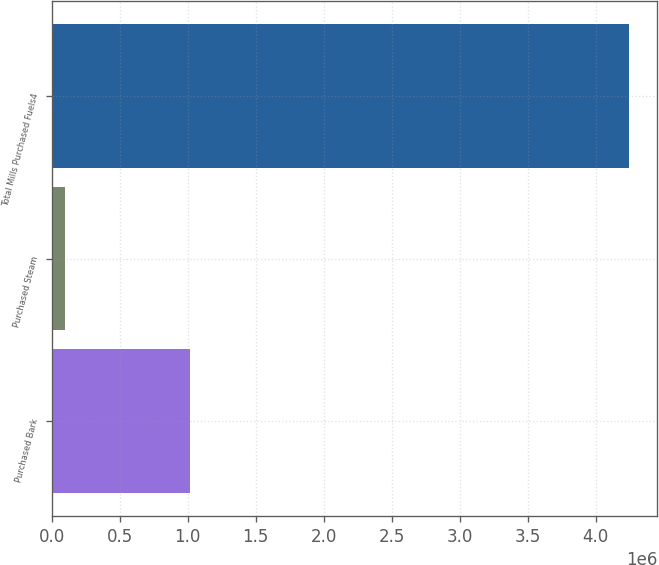<chart> <loc_0><loc_0><loc_500><loc_500><bar_chart><fcel>Purchased Bark<fcel>Purchased Steam<fcel>Total Mills Purchased Fuels4<nl><fcel>1.01758e+06<fcel>99739<fcel>4.24218e+06<nl></chart> 